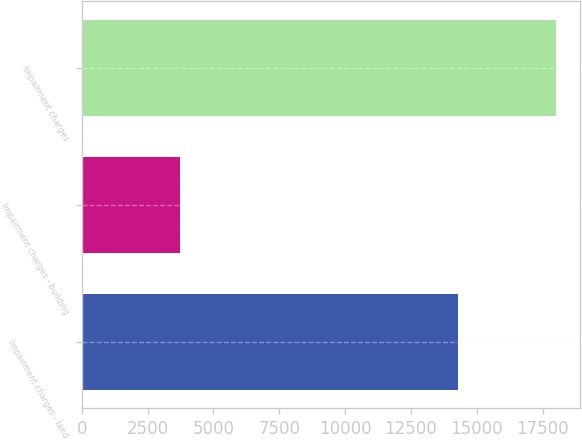<chart> <loc_0><loc_0><loc_500><loc_500><bar_chart><fcel>Impairment charges - land<fcel>Impairment charges - building<fcel>Impairment charges<nl><fcel>14299<fcel>3719<fcel>18018<nl></chart> 